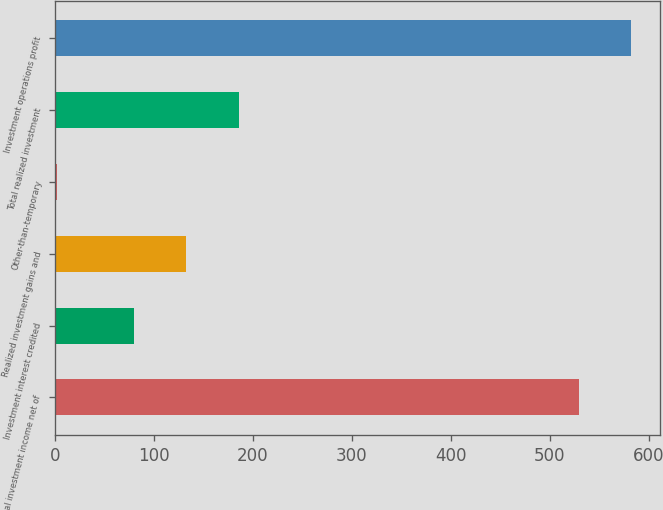Convert chart to OTSL. <chart><loc_0><loc_0><loc_500><loc_500><bar_chart><fcel>Total investment income net of<fcel>Investment interest credited<fcel>Realized investment gains and<fcel>Other-than-temporary<fcel>Total realized investment<fcel>Investment operations profit<nl><fcel>529<fcel>80<fcel>133<fcel>2<fcel>186<fcel>582<nl></chart> 